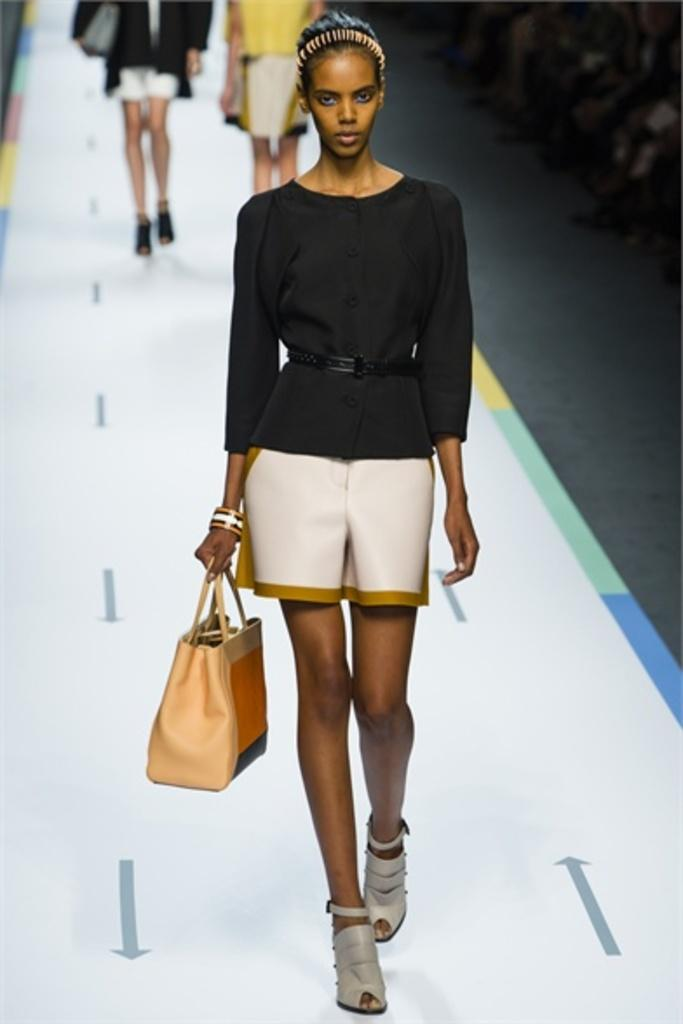What is the person in the image doing? There is a person walking on the ramp in the image. What is the person holding while walking? The person is holding a bag. Are there any other people in the image? Yes, there are two more people walking behind the first person. Can you see any caves in the background of the image? There is no mention of a cave or any background in the provided facts, so it cannot be determined if there are any caves in the image. 